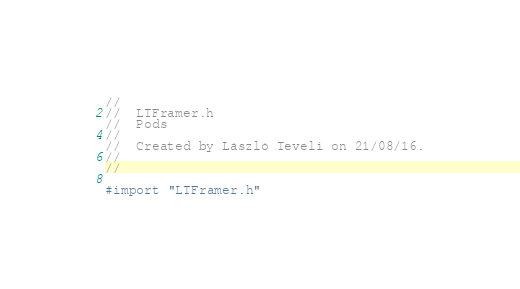Convert code to text. <code><loc_0><loc_0><loc_500><loc_500><_C_>//
//  LTFramer.h
//  Pods
//
//  Created by László Teveli on 21/08/16.
//
//

#import "LTFramer.h"
</code> 